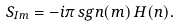Convert formula to latex. <formula><loc_0><loc_0><loc_500><loc_500>S _ { I m } = - i \pi \, s g n ( m ) \, H ( n ) .</formula> 